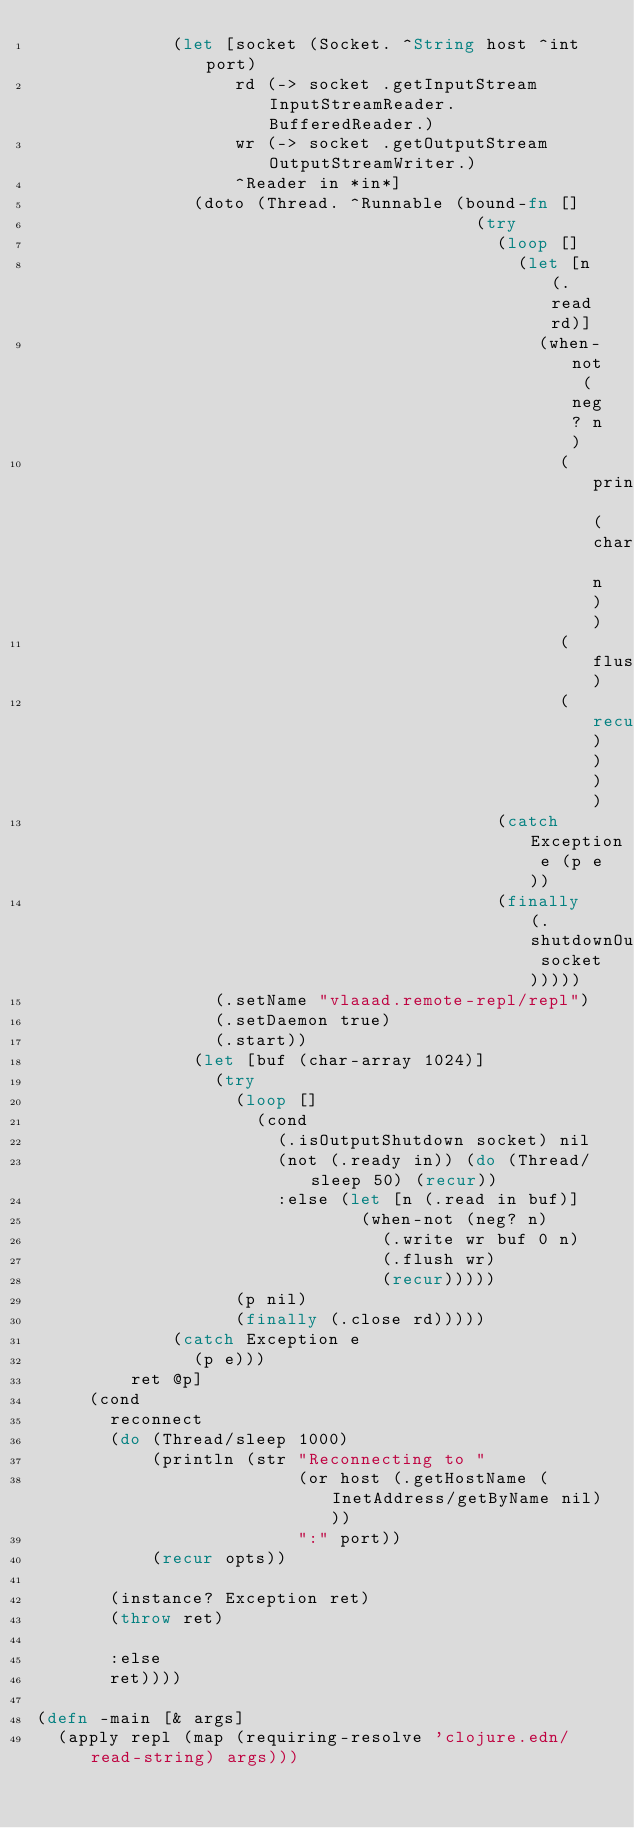<code> <loc_0><loc_0><loc_500><loc_500><_Clojure_>             (let [socket (Socket. ^String host ^int port)
                   rd (-> socket .getInputStream InputStreamReader. BufferedReader.)
                   wr (-> socket .getOutputStream OutputStreamWriter.)
                   ^Reader in *in*]
               (doto (Thread. ^Runnable (bound-fn []
                                          (try
                                            (loop []
                                              (let [n (.read rd)]
                                                (when-not (neg? n)
                                                  (print (char n))
                                                  (flush)
                                                  (recur))))
                                            (catch Exception e (p e))
                                            (finally (.shutdownOutput socket)))))
                 (.setName "vlaaad.remote-repl/repl")
                 (.setDaemon true)
                 (.start))
               (let [buf (char-array 1024)]
                 (try
                   (loop []
                     (cond
                       (.isOutputShutdown socket) nil
                       (not (.ready in)) (do (Thread/sleep 50) (recur))
                       :else (let [n (.read in buf)]
                               (when-not (neg? n)
                                 (.write wr buf 0 n)
                                 (.flush wr)
                                 (recur)))))
                   (p nil)
                   (finally (.close rd)))))
             (catch Exception e
               (p e)))
         ret @p]
     (cond
       reconnect
       (do (Thread/sleep 1000)
           (println (str "Reconnecting to "
                         (or host (.getHostName (InetAddress/getByName nil)))
                         ":" port))
           (recur opts))

       (instance? Exception ret)
       (throw ret)

       :else
       ret))))

(defn -main [& args]
  (apply repl (map (requiring-resolve 'clojure.edn/read-string) args)))</code> 